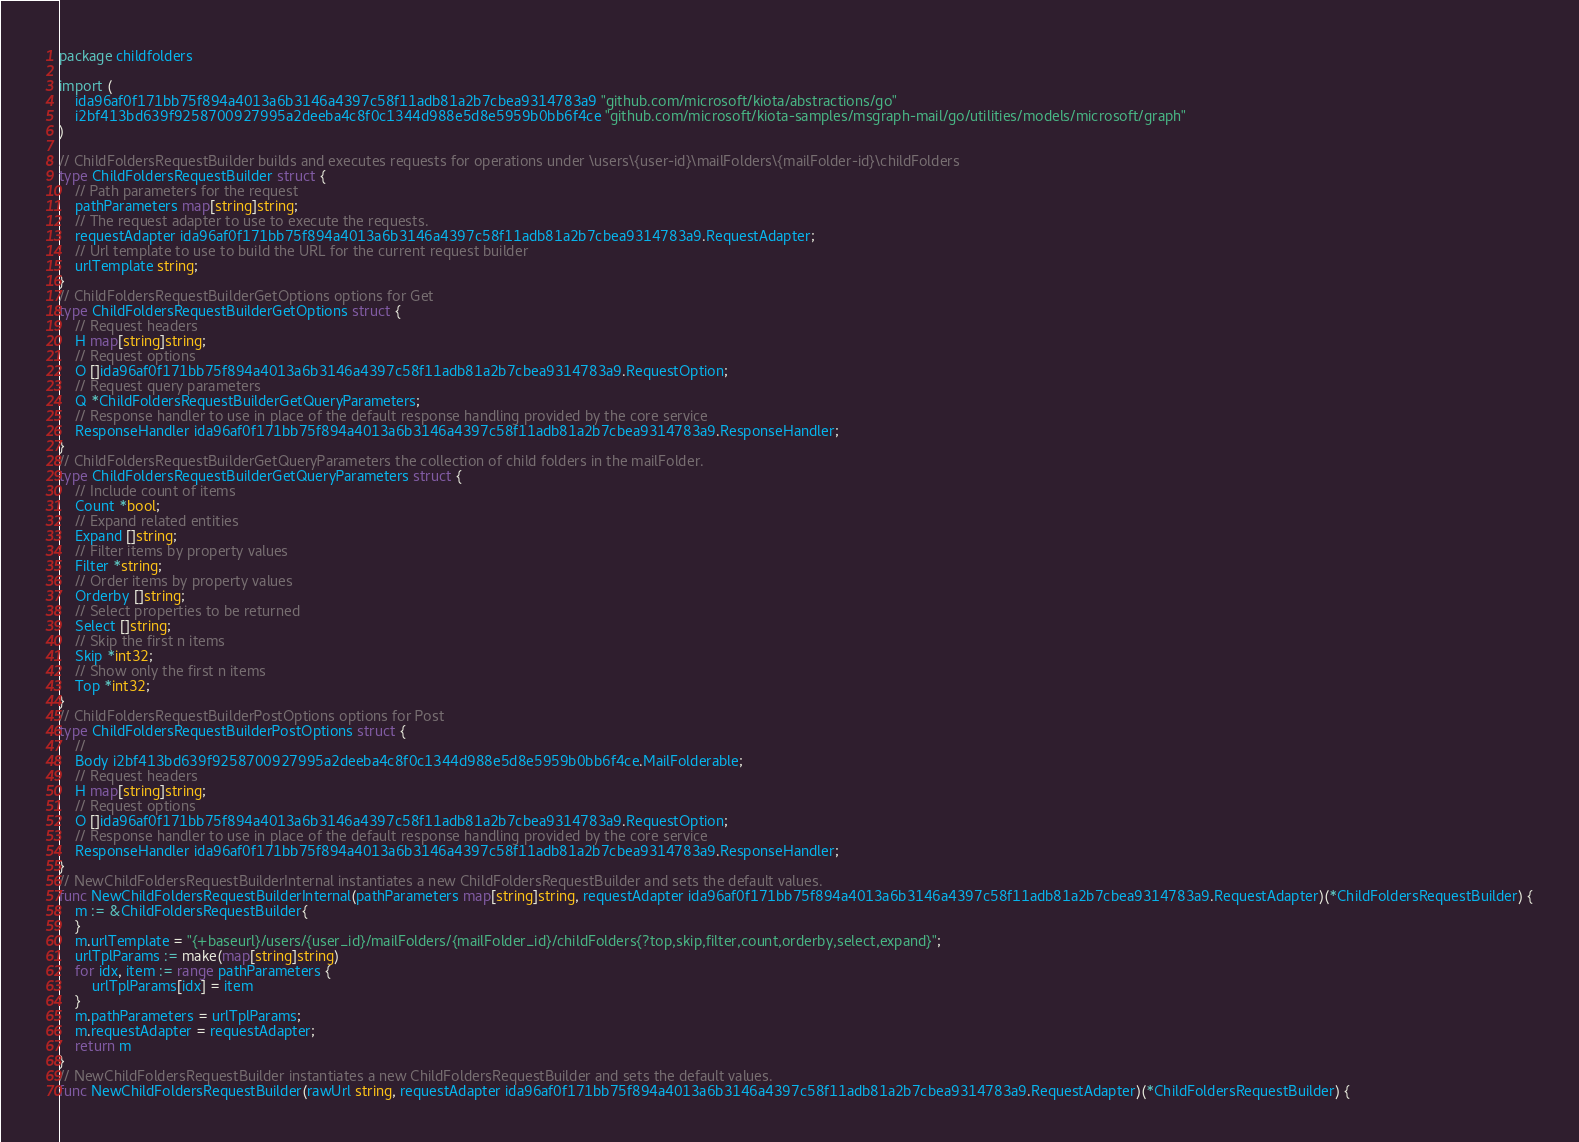Convert code to text. <code><loc_0><loc_0><loc_500><loc_500><_Go_>package childfolders

import (
    ida96af0f171bb75f894a4013a6b3146a4397c58f11adb81a2b7cbea9314783a9 "github.com/microsoft/kiota/abstractions/go"
    i2bf413bd639f9258700927995a2deeba4c8f0c1344d988e5d8e5959b0bb6f4ce "github.com/microsoft/kiota-samples/msgraph-mail/go/utilities/models/microsoft/graph"
)

// ChildFoldersRequestBuilder builds and executes requests for operations under \users\{user-id}\mailFolders\{mailFolder-id}\childFolders
type ChildFoldersRequestBuilder struct {
    // Path parameters for the request
    pathParameters map[string]string;
    // The request adapter to use to execute the requests.
    requestAdapter ida96af0f171bb75f894a4013a6b3146a4397c58f11adb81a2b7cbea9314783a9.RequestAdapter;
    // Url template to use to build the URL for the current request builder
    urlTemplate string;
}
// ChildFoldersRequestBuilderGetOptions options for Get
type ChildFoldersRequestBuilderGetOptions struct {
    // Request headers
    H map[string]string;
    // Request options
    O []ida96af0f171bb75f894a4013a6b3146a4397c58f11adb81a2b7cbea9314783a9.RequestOption;
    // Request query parameters
    Q *ChildFoldersRequestBuilderGetQueryParameters;
    // Response handler to use in place of the default response handling provided by the core service
    ResponseHandler ida96af0f171bb75f894a4013a6b3146a4397c58f11adb81a2b7cbea9314783a9.ResponseHandler;
}
// ChildFoldersRequestBuilderGetQueryParameters the collection of child folders in the mailFolder.
type ChildFoldersRequestBuilderGetQueryParameters struct {
    // Include count of items
    Count *bool;
    // Expand related entities
    Expand []string;
    // Filter items by property values
    Filter *string;
    // Order items by property values
    Orderby []string;
    // Select properties to be returned
    Select []string;
    // Skip the first n items
    Skip *int32;
    // Show only the first n items
    Top *int32;
}
// ChildFoldersRequestBuilderPostOptions options for Post
type ChildFoldersRequestBuilderPostOptions struct {
    // 
    Body i2bf413bd639f9258700927995a2deeba4c8f0c1344d988e5d8e5959b0bb6f4ce.MailFolderable;
    // Request headers
    H map[string]string;
    // Request options
    O []ida96af0f171bb75f894a4013a6b3146a4397c58f11adb81a2b7cbea9314783a9.RequestOption;
    // Response handler to use in place of the default response handling provided by the core service
    ResponseHandler ida96af0f171bb75f894a4013a6b3146a4397c58f11adb81a2b7cbea9314783a9.ResponseHandler;
}
// NewChildFoldersRequestBuilderInternal instantiates a new ChildFoldersRequestBuilder and sets the default values.
func NewChildFoldersRequestBuilderInternal(pathParameters map[string]string, requestAdapter ida96af0f171bb75f894a4013a6b3146a4397c58f11adb81a2b7cbea9314783a9.RequestAdapter)(*ChildFoldersRequestBuilder) {
    m := &ChildFoldersRequestBuilder{
    }
    m.urlTemplate = "{+baseurl}/users/{user_id}/mailFolders/{mailFolder_id}/childFolders{?top,skip,filter,count,orderby,select,expand}";
    urlTplParams := make(map[string]string)
    for idx, item := range pathParameters {
        urlTplParams[idx] = item
    }
    m.pathParameters = urlTplParams;
    m.requestAdapter = requestAdapter;
    return m
}
// NewChildFoldersRequestBuilder instantiates a new ChildFoldersRequestBuilder and sets the default values.
func NewChildFoldersRequestBuilder(rawUrl string, requestAdapter ida96af0f171bb75f894a4013a6b3146a4397c58f11adb81a2b7cbea9314783a9.RequestAdapter)(*ChildFoldersRequestBuilder) {</code> 